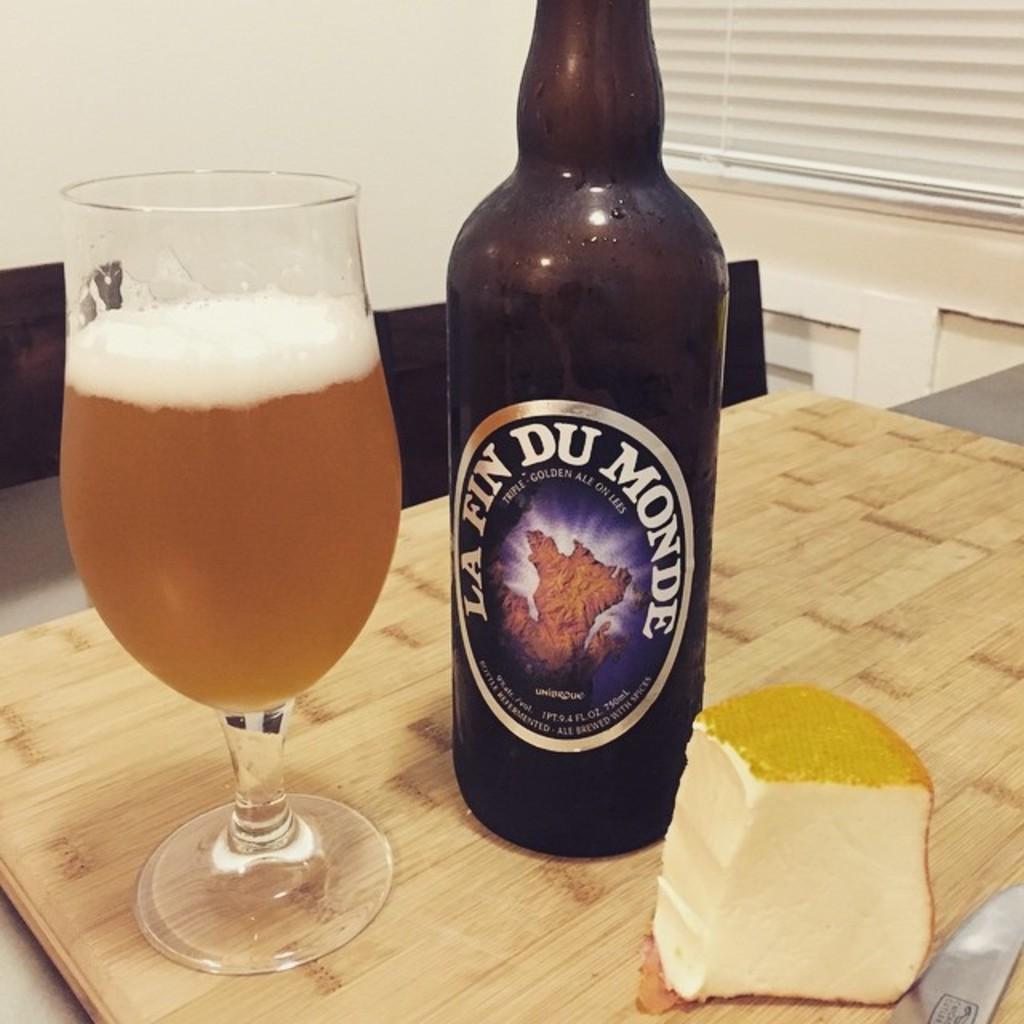Does their slogan say they are the "golden ale"?
Offer a very short reply. Yes. 